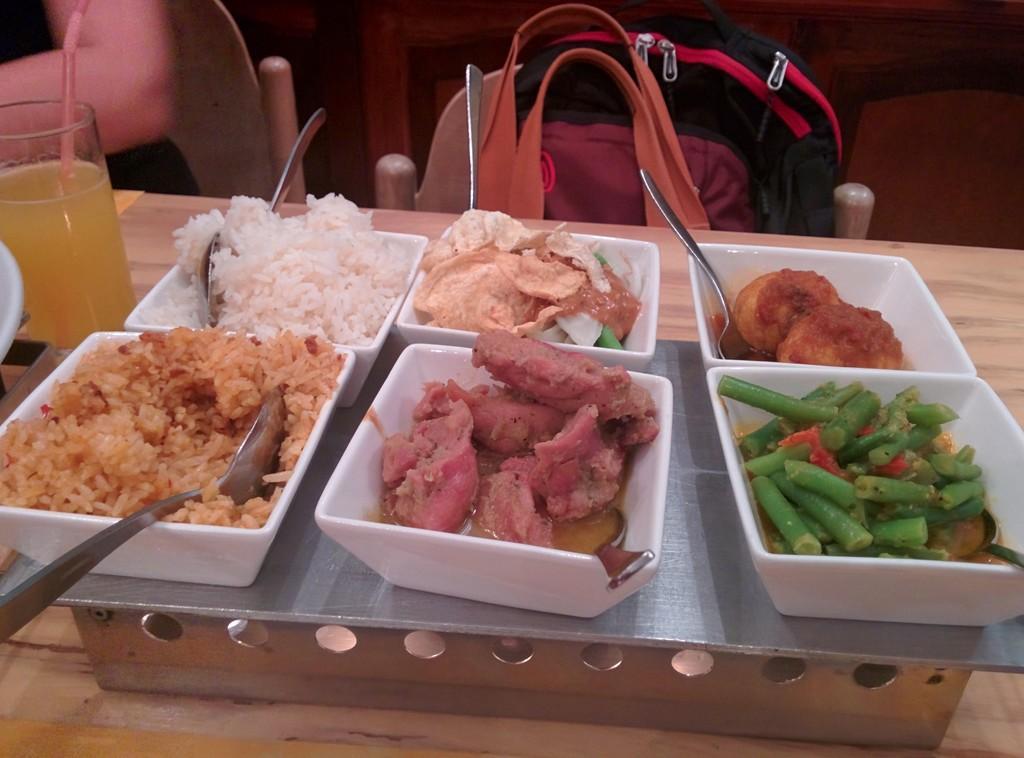Can you describe this image briefly? In this image there are different dishes and a glass on the table. There is a bag on the chair and at the left of the image there is a person sitting on the chair. 